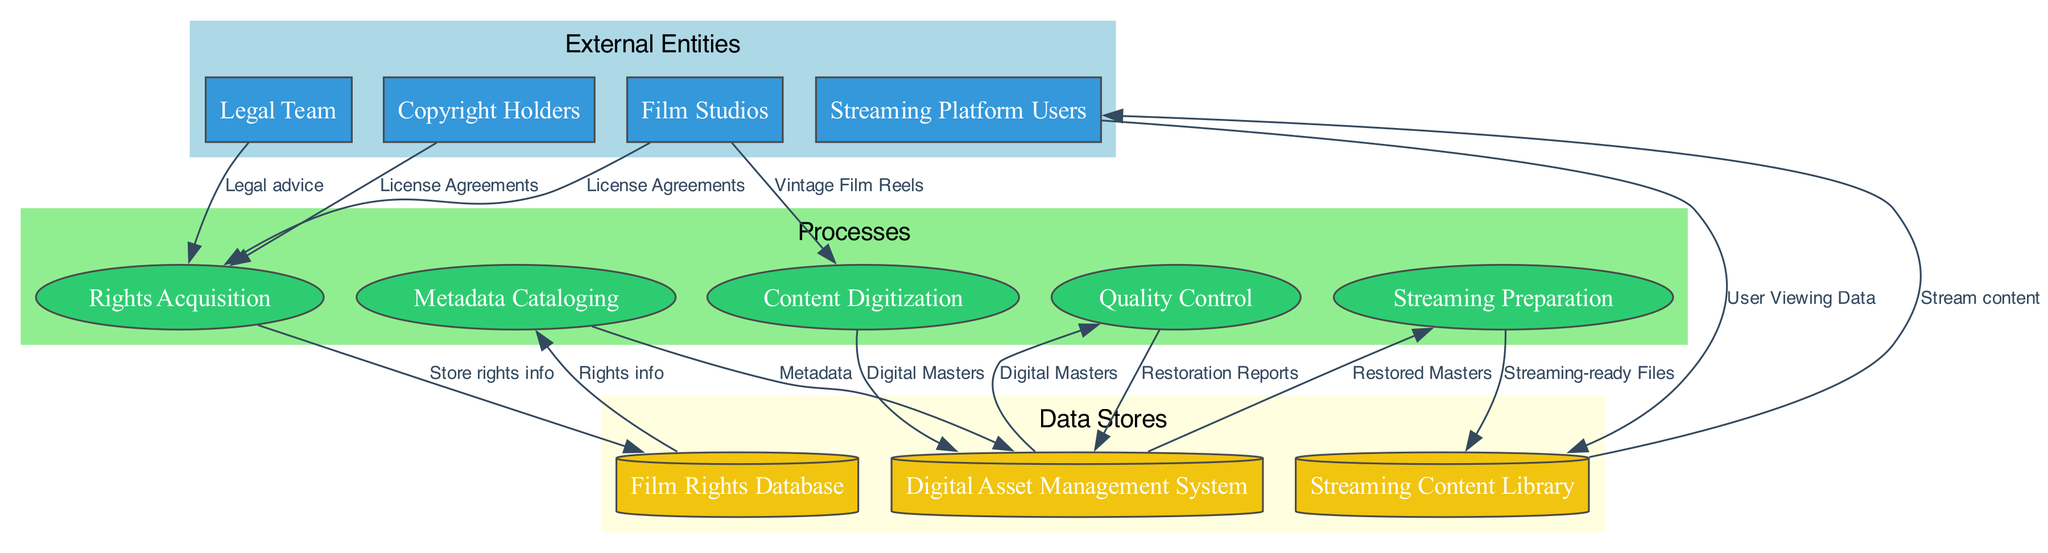What are the external entities involved in the system? The diagram shows four external entities: Film Studios, Copyright Holders, Legal Team, and Streaming Platform Users.
Answer: Film Studios, Copyright Holders, Legal Team, Streaming Platform Users How many processes are depicted in the diagram? There are five processes in the diagram: Rights Acquisition, Metadata Cataloging, Content Digitization, Quality Control, and Streaming Preparation, which totals five.
Answer: 5 What data flows into the Quality Control process? The Quality Control process receives data from the Digital Asset Management System, specifically the Digital Masters, and returns Restoration Reports, indicating that it relies on the processed data from the prior step.
Answer: Digital Masters Which data store is associated with streaming-ready files? The Streaming Content Library is the data store where Streaming-ready Files are sent after processing through Streaming Preparation.
Answer: Streaming Content Library What type of data flows from Streaming Platform Users to the Streaming Content Library? The Streaming Platform Users provide User Viewing Data back to the Streaming Content Library, indicating feedback or usage information related to the streaming service.
Answer: User Viewing Data What is the relationship between Rights Acquisition and Film Rights Database? The Rights Acquisition process stores rights information into the Film Rights Database, highlighting its role in managing and preserving licensing details.
Answer: Store rights info Which process is responsible for digital mastering? Content Digitization is the process responsible for creating Digital Masters from Vintage Film Reels, focusing on converting physical media into digital formats.
Answer: Content Digitization How many edges connect the external entities to the Rights Acquisition process? There are two edges from external entities (Film Studios and Copyright Holders) connecting to the Rights Acquisition process, indicating that both parties are involved in licensing agreements.
Answer: 2 Which data flow provides legal advice to the Rights Acquisition process? The Legal Team provides Legal advice as a data flow to the Rights Acquisition process, ensuring compliance and correctness in the acquisition of film rights.
Answer: Legal advice What data store receives metadata from the Metadata Cataloging process? The Digital Asset Management System receives Metadata from the Metadata Cataloging process, indicating a database structure where contextual information about the films is stored.
Answer: Digital Asset Management System 